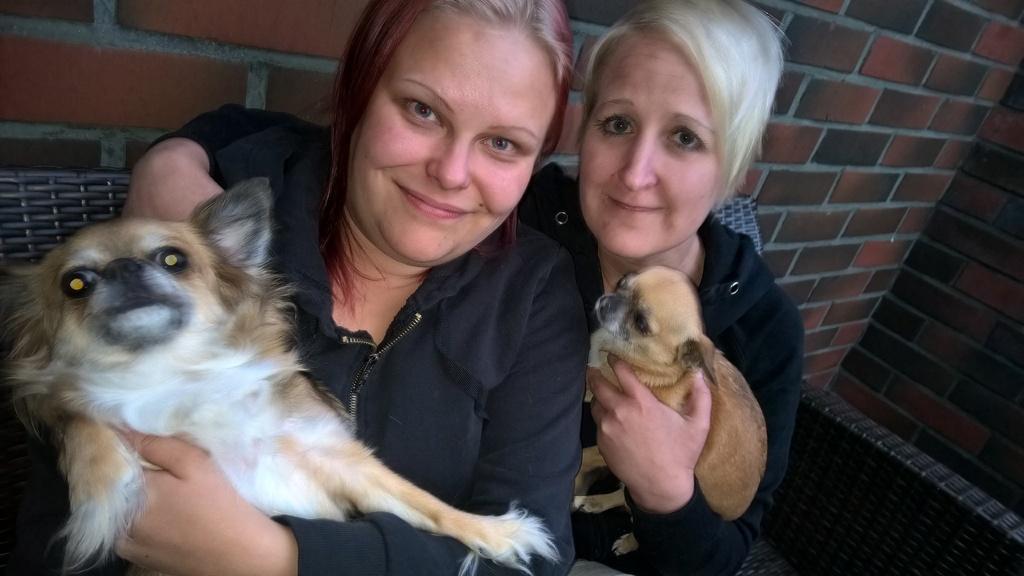Can you describe this image briefly? In this image I can see two women and both of them are holding dogs. I can also see smile on their faces and both of them are wearing jackets. 